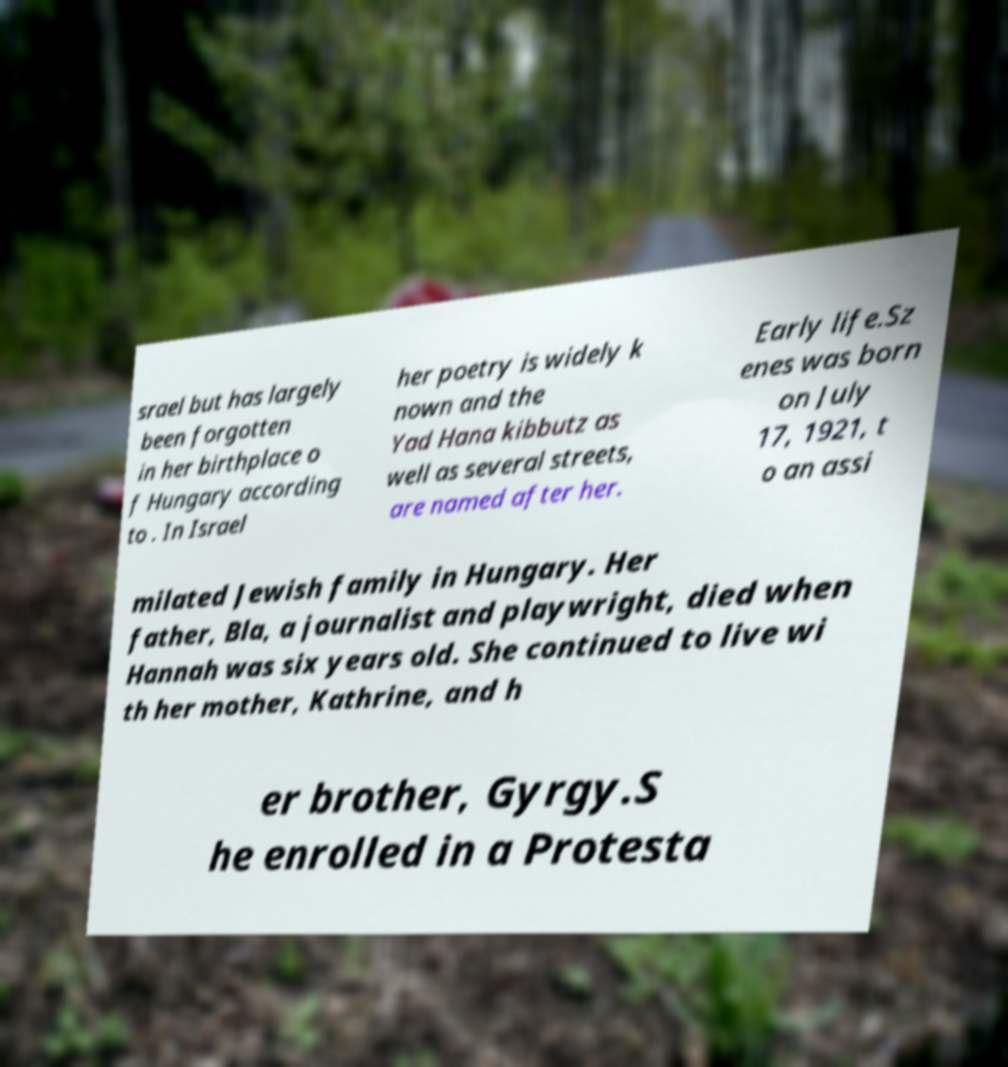Can you read and provide the text displayed in the image?This photo seems to have some interesting text. Can you extract and type it out for me? srael but has largely been forgotten in her birthplace o f Hungary according to . In Israel her poetry is widely k nown and the Yad Hana kibbutz as well as several streets, are named after her. Early life.Sz enes was born on July 17, 1921, t o an assi milated Jewish family in Hungary. Her father, Bla, a journalist and playwright, died when Hannah was six years old. She continued to live wi th her mother, Kathrine, and h er brother, Gyrgy.S he enrolled in a Protesta 